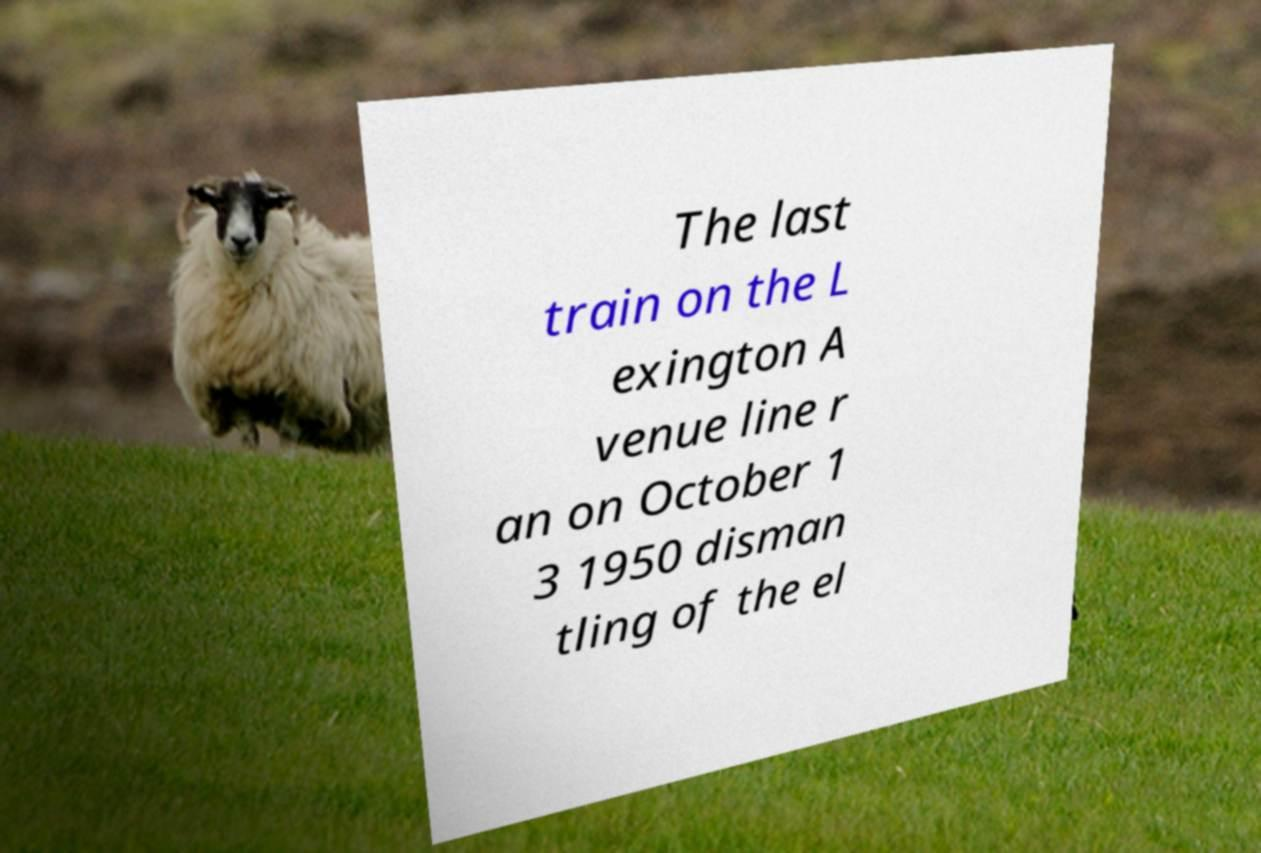There's text embedded in this image that I need extracted. Can you transcribe it verbatim? The last train on the L exington A venue line r an on October 1 3 1950 disman tling of the el 